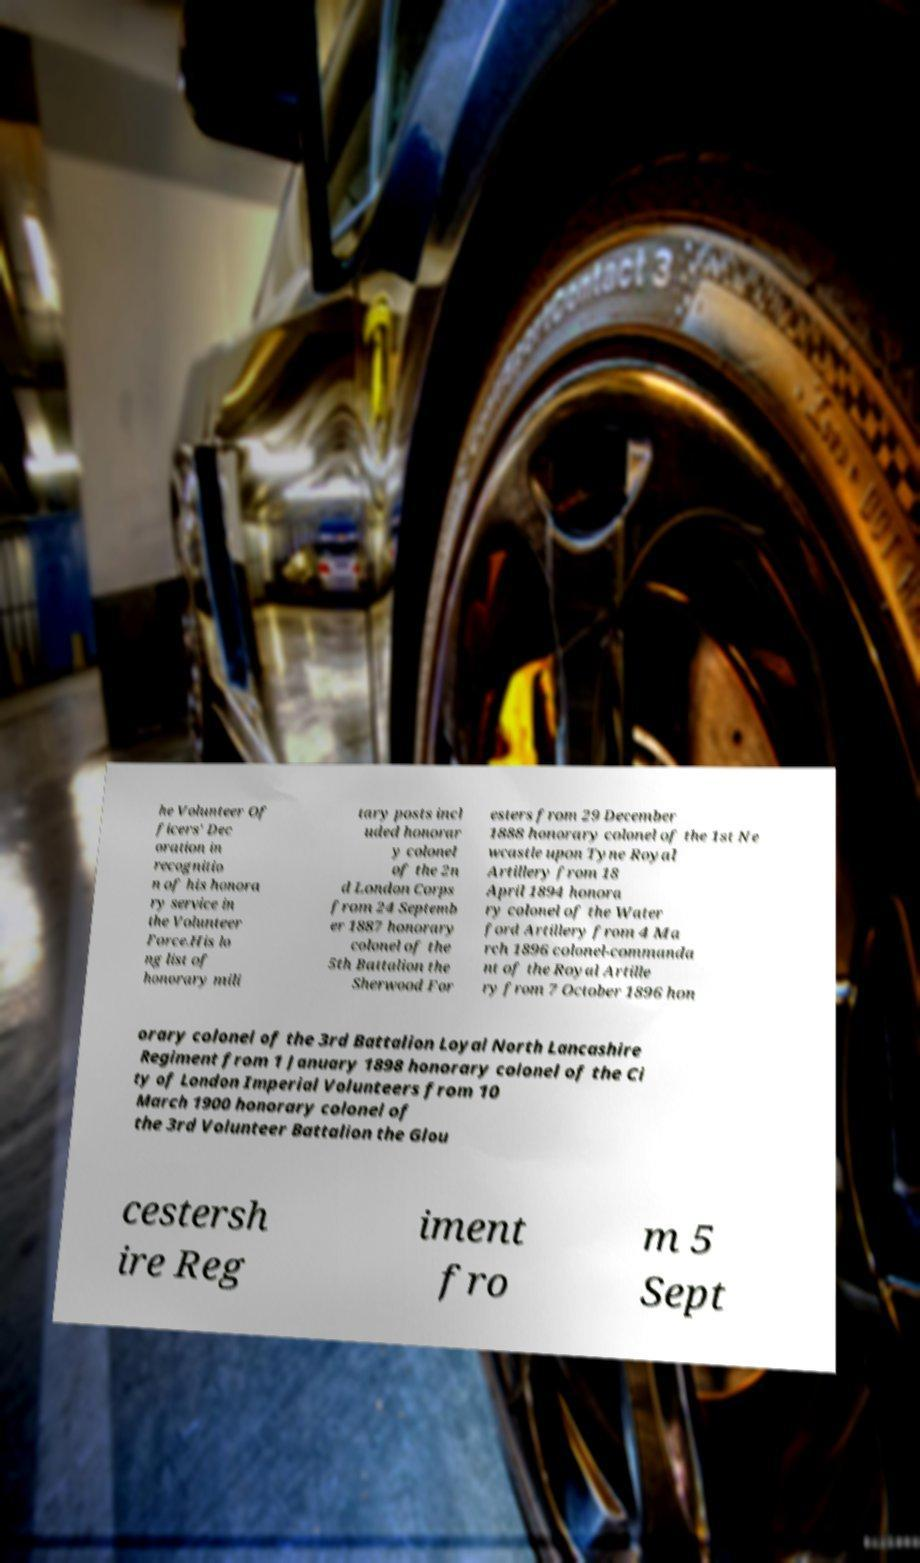Please identify and transcribe the text found in this image. he Volunteer Of ficers' Dec oration in recognitio n of his honora ry service in the Volunteer Force.His lo ng list of honorary mili tary posts incl uded honorar y colonel of the 2n d London Corps from 24 Septemb er 1887 honorary colonel of the 5th Battalion the Sherwood For esters from 29 December 1888 honorary colonel of the 1st Ne wcastle upon Tyne Royal Artillery from 18 April 1894 honora ry colonel of the Water ford Artillery from 4 Ma rch 1896 colonel-commanda nt of the Royal Artille ry from 7 October 1896 hon orary colonel of the 3rd Battalion Loyal North Lancashire Regiment from 1 January 1898 honorary colonel of the Ci ty of London Imperial Volunteers from 10 March 1900 honorary colonel of the 3rd Volunteer Battalion the Glou cestersh ire Reg iment fro m 5 Sept 